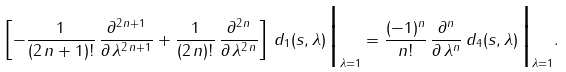Convert formula to latex. <formula><loc_0><loc_0><loc_500><loc_500>\left [ - \frac { 1 } { ( 2 \, n + 1 ) ! } \, \frac { \partial ^ { 2 \, n + 1 } } { \partial \, \lambda ^ { 2 \, n + 1 } } + \frac { 1 } { ( 2 \, n ) ! } \, \frac { \partial ^ { 2 \, n } } { \partial \, \lambda ^ { 2 \, n } } \right ] \, d _ { 1 } ( s , \lambda ) \, \Big { | } _ { \lambda = 1 } = \frac { ( - 1 ) ^ { n } } { n ! } \, \frac { \partial ^ { n } } { \partial \, \lambda ^ { n } } \, d _ { 4 } ( s , \lambda ) \, \Big { | } _ { \lambda = 1 } .</formula> 